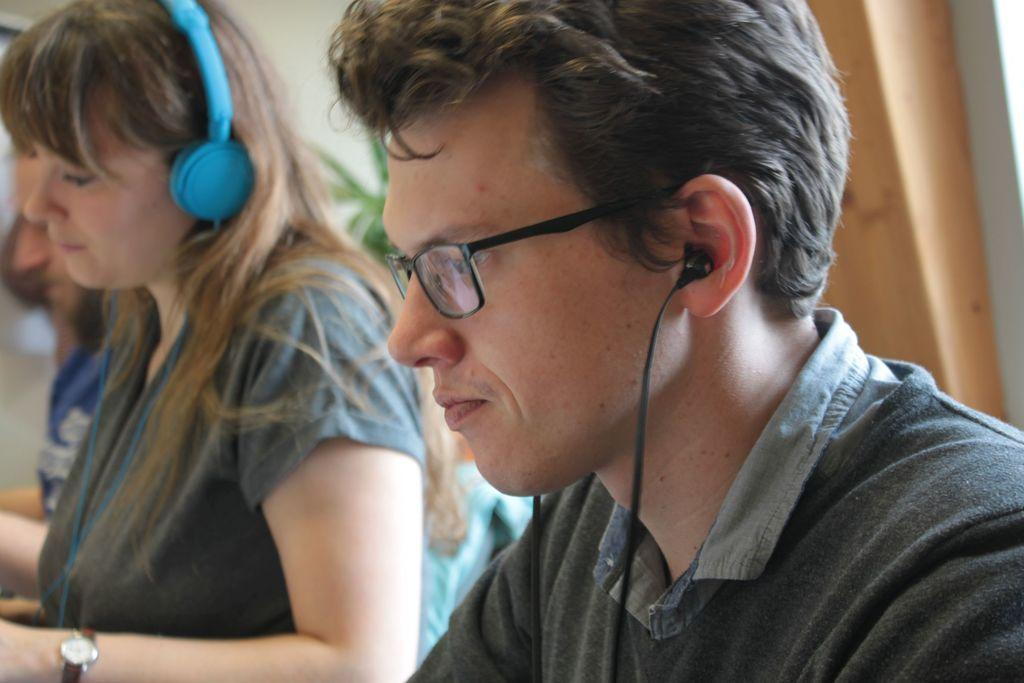How many people are present in the image? There are two people, a man and a woman, present in the image. What can be seen in the background of the image? There is a wall, a plant, a person, and an object in the background of the image. Can you describe the setting where the man and woman are located? The man and woman are in a setting with a wall and various objects in the background. What book is the man reading in the image? There is no book or reading activity depicted in the image. 